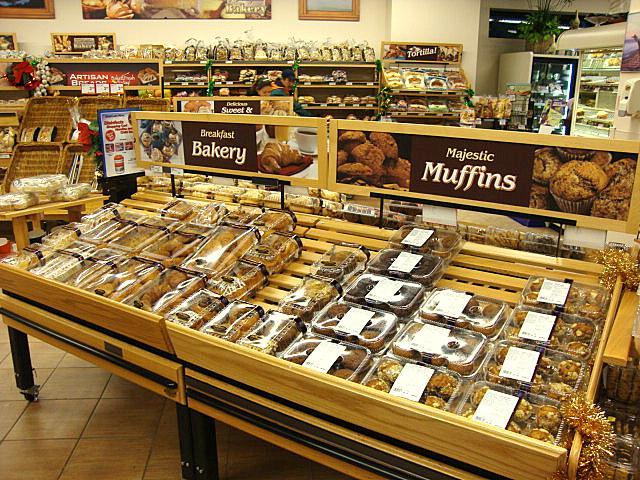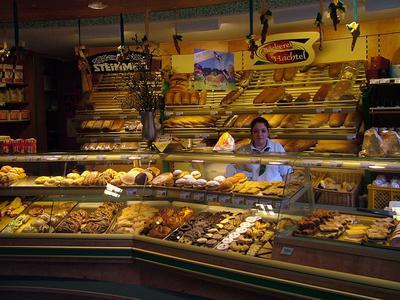The first image is the image on the left, the second image is the image on the right. Examine the images to the left and right. Is the description "In the left image, the word bakery is present." accurate? Answer yes or no. Yes. The first image is the image on the left, the second image is the image on the right. For the images shown, is this caption "The right image shows at least one person in a hat standing behind a straight glass-fronted cabinet filled with baked treats." true? Answer yes or no. No. 